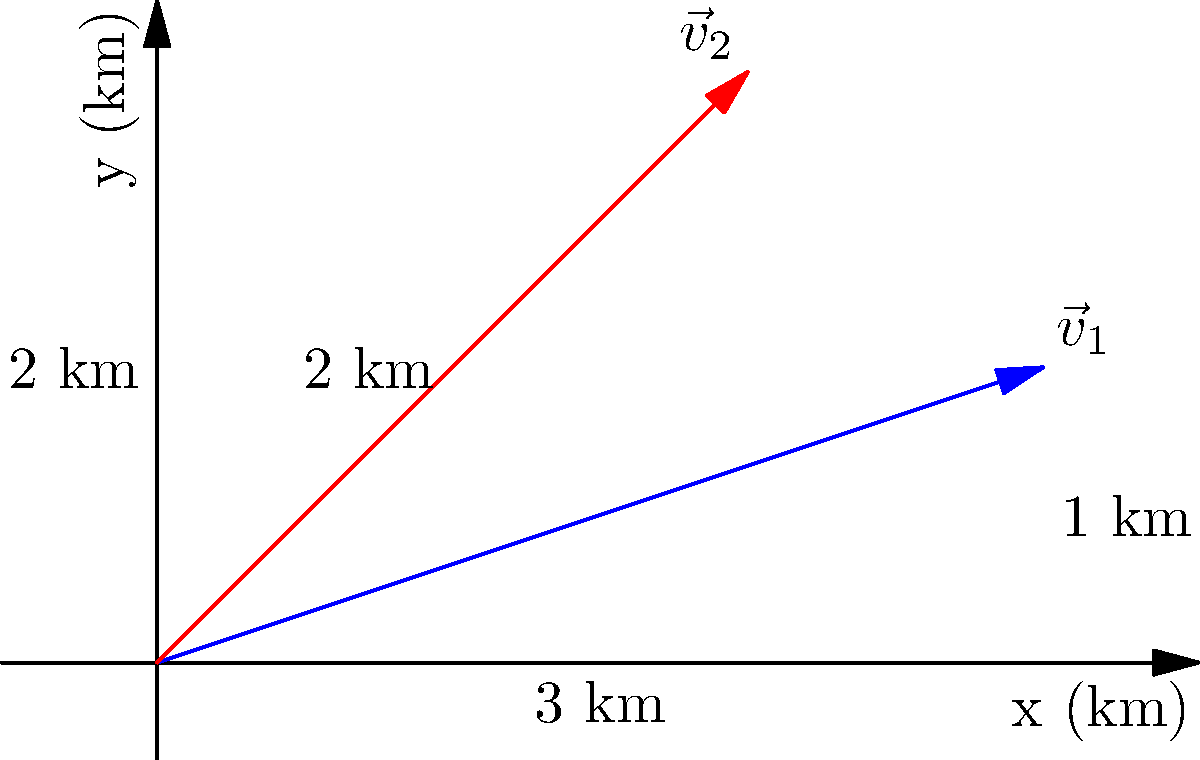A glacier's movement is monitored over two consecutive days. On day 1, it moves 3 km east and 1 km north, represented by vector $\vec{v}_1$. On day 2, it moves 2 km east and 2 km north, represented by vector $\vec{v}_2$. Calculate the glacier's average velocity vector over the two-day period. To calculate the average velocity vector, we need to follow these steps:

1. Find the total displacement vector:
   - Add the two displacement vectors: $\vec{v}_{\text{total}} = \vec{v}_1 + \vec{v}_2$
   - $\vec{v}_1 = (3,1)$ and $\vec{v}_2 = (2,2)$
   - $\vec{v}_{\text{total}} = (3,1) + (2,2) = (5,3)$

2. Calculate the time period:
   - The movement occurred over two days, so $t = 2$ days

3. Calculate the average velocity vector:
   - Average velocity = Total displacement / Time
   - $\vec{v}_{\text{avg}} = \vec{v}_{\text{total}} / t = (5,3) / 2 = (2.5, 1.5)$

4. Interpret the result:
   - The average velocity is 2.5 km/day east and 1.5 km/day north

Therefore, the average velocity vector is $\vec{v}_{\text{avg}} = (2.5, 1.5)$ km/day.
Answer: $(2.5, 1.5)$ km/day 